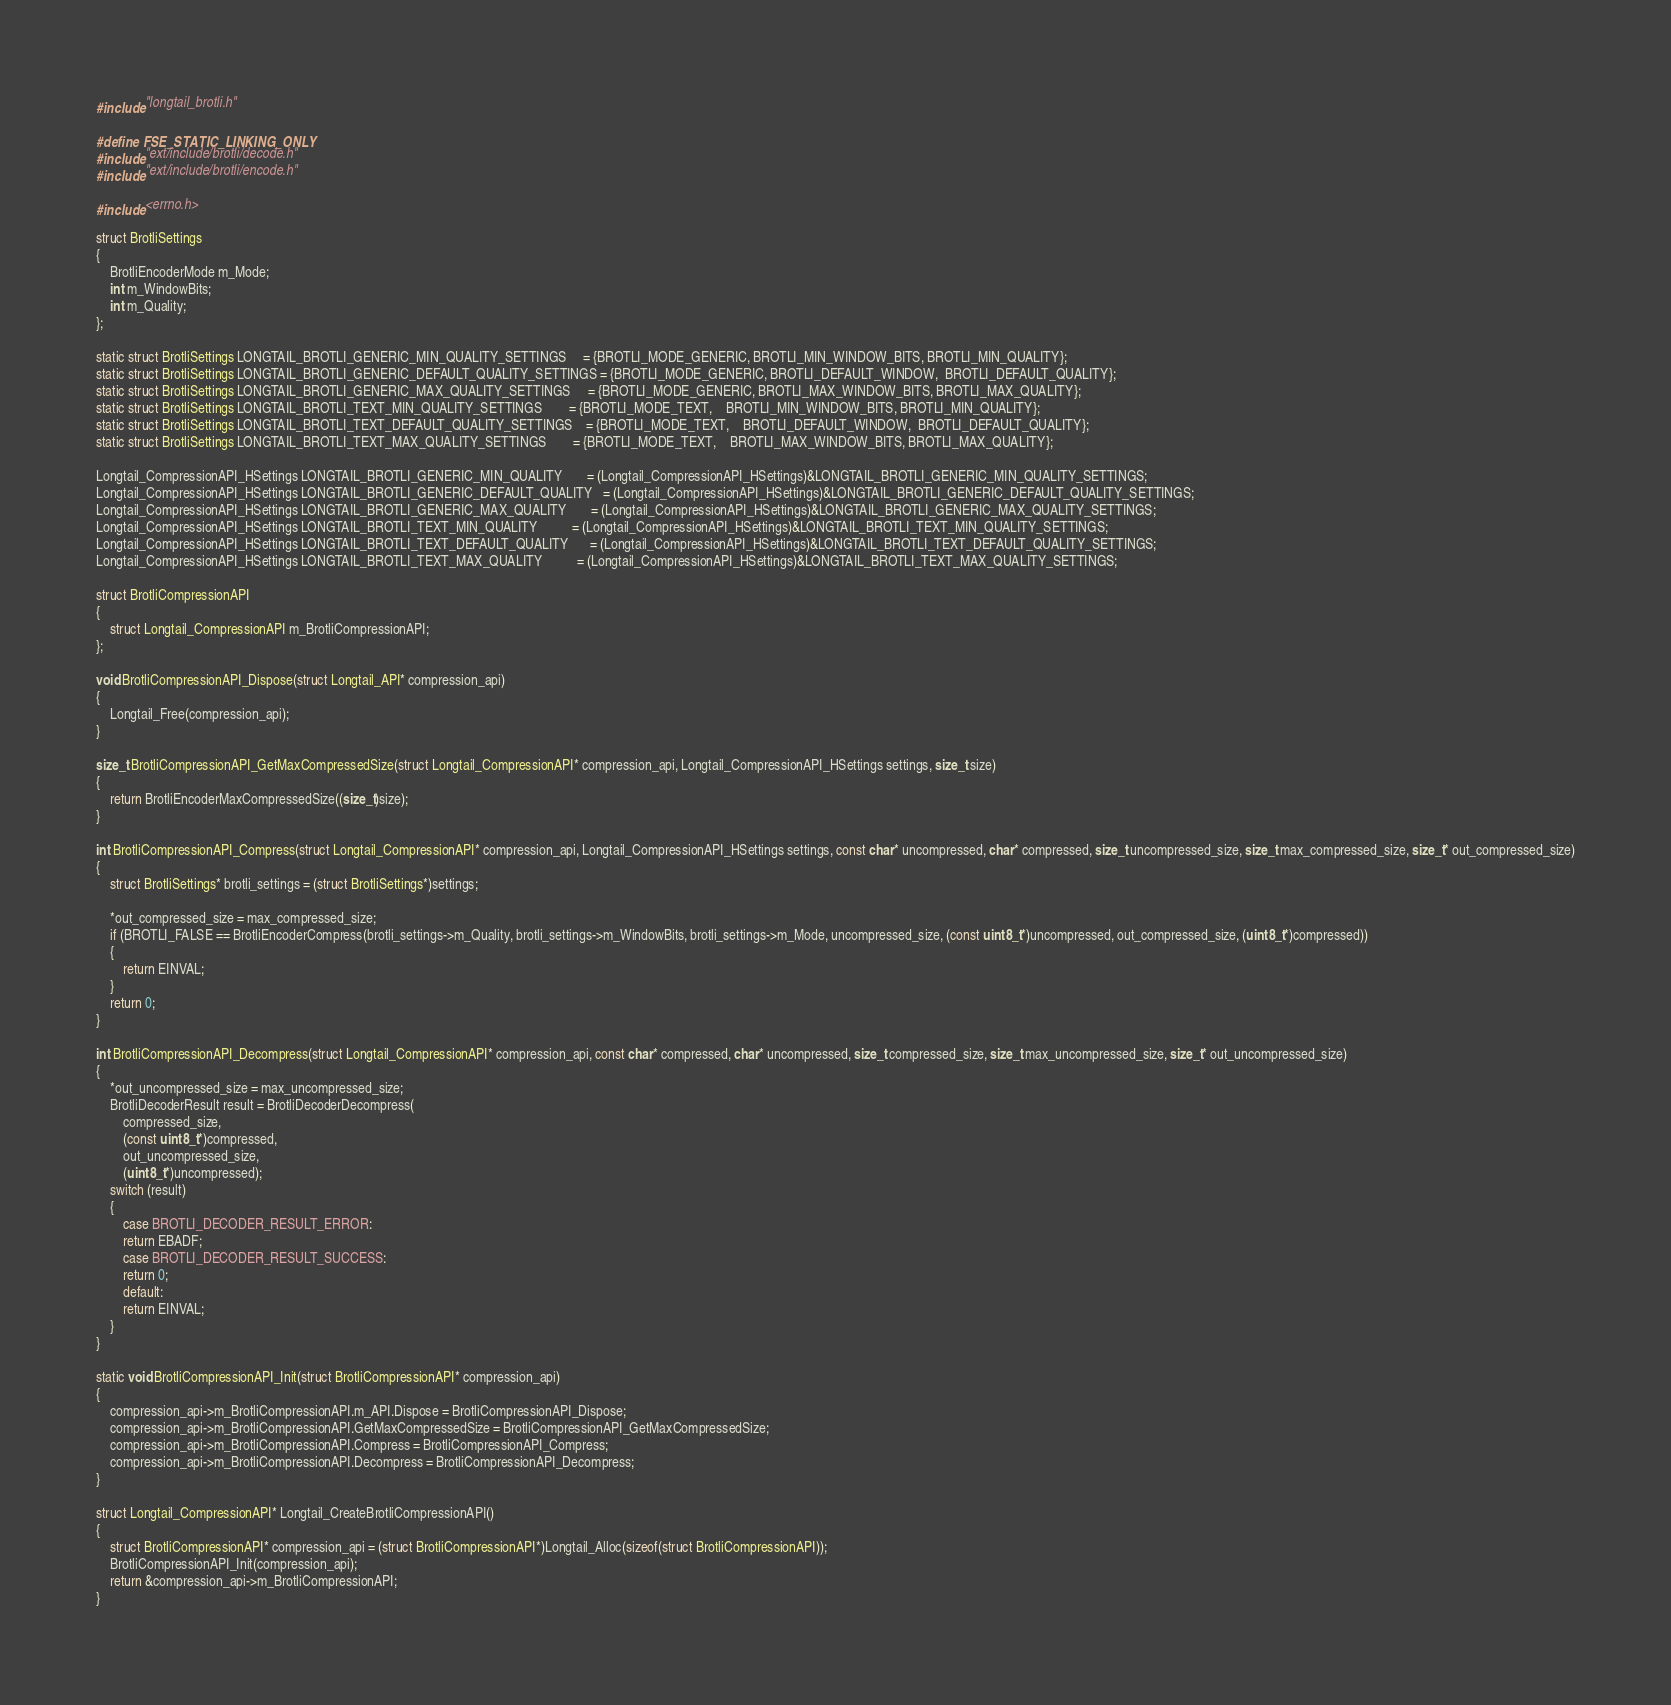Convert code to text. <code><loc_0><loc_0><loc_500><loc_500><_C_>#include "longtail_brotli.h"

#define FSE_STATIC_LINKING_ONLY
#include "ext/include/brotli/decode.h"
#include "ext/include/brotli/encode.h"

#include <errno.h>

struct BrotliSettings
{
    BrotliEncoderMode m_Mode;
    int m_WindowBits;
    int m_Quality;
};

static struct BrotliSettings LONGTAIL_BROTLI_GENERIC_MIN_QUALITY_SETTINGS     = {BROTLI_MODE_GENERIC, BROTLI_MIN_WINDOW_BITS, BROTLI_MIN_QUALITY};
static struct BrotliSettings LONGTAIL_BROTLI_GENERIC_DEFAULT_QUALITY_SETTINGS = {BROTLI_MODE_GENERIC, BROTLI_DEFAULT_WINDOW,  BROTLI_DEFAULT_QUALITY};
static struct BrotliSettings LONGTAIL_BROTLI_GENERIC_MAX_QUALITY_SETTINGS     = {BROTLI_MODE_GENERIC, BROTLI_MAX_WINDOW_BITS, BROTLI_MAX_QUALITY};
static struct BrotliSettings LONGTAIL_BROTLI_TEXT_MIN_QUALITY_SETTINGS        = {BROTLI_MODE_TEXT,    BROTLI_MIN_WINDOW_BITS, BROTLI_MIN_QUALITY};
static struct BrotliSettings LONGTAIL_BROTLI_TEXT_DEFAULT_QUALITY_SETTINGS    = {BROTLI_MODE_TEXT,    BROTLI_DEFAULT_WINDOW,  BROTLI_DEFAULT_QUALITY};
static struct BrotliSettings LONGTAIL_BROTLI_TEXT_MAX_QUALITY_SETTINGS        = {BROTLI_MODE_TEXT,    BROTLI_MAX_WINDOW_BITS, BROTLI_MAX_QUALITY};

Longtail_CompressionAPI_HSettings LONGTAIL_BROTLI_GENERIC_MIN_QUALITY       = (Longtail_CompressionAPI_HSettings)&LONGTAIL_BROTLI_GENERIC_MIN_QUALITY_SETTINGS;
Longtail_CompressionAPI_HSettings LONGTAIL_BROTLI_GENERIC_DEFAULT_QUALITY   = (Longtail_CompressionAPI_HSettings)&LONGTAIL_BROTLI_GENERIC_DEFAULT_QUALITY_SETTINGS;
Longtail_CompressionAPI_HSettings LONGTAIL_BROTLI_GENERIC_MAX_QUALITY       = (Longtail_CompressionAPI_HSettings)&LONGTAIL_BROTLI_GENERIC_MAX_QUALITY_SETTINGS;
Longtail_CompressionAPI_HSettings LONGTAIL_BROTLI_TEXT_MIN_QUALITY          = (Longtail_CompressionAPI_HSettings)&LONGTAIL_BROTLI_TEXT_MIN_QUALITY_SETTINGS;
Longtail_CompressionAPI_HSettings LONGTAIL_BROTLI_TEXT_DEFAULT_QUALITY      = (Longtail_CompressionAPI_HSettings)&LONGTAIL_BROTLI_TEXT_DEFAULT_QUALITY_SETTINGS;
Longtail_CompressionAPI_HSettings LONGTAIL_BROTLI_TEXT_MAX_QUALITY          = (Longtail_CompressionAPI_HSettings)&LONGTAIL_BROTLI_TEXT_MAX_QUALITY_SETTINGS;

struct BrotliCompressionAPI
{
    struct Longtail_CompressionAPI m_BrotliCompressionAPI;
};

void BrotliCompressionAPI_Dispose(struct Longtail_API* compression_api)
{
    Longtail_Free(compression_api);
}

size_t BrotliCompressionAPI_GetMaxCompressedSize(struct Longtail_CompressionAPI* compression_api, Longtail_CompressionAPI_HSettings settings, size_t size)
{
    return BrotliEncoderMaxCompressedSize((size_t)size);
}

int BrotliCompressionAPI_Compress(struct Longtail_CompressionAPI* compression_api, Longtail_CompressionAPI_HSettings settings, const char* uncompressed, char* compressed, size_t uncompressed_size, size_t max_compressed_size, size_t* out_compressed_size)
{
    struct BrotliSettings* brotli_settings = (struct BrotliSettings*)settings;

    *out_compressed_size = max_compressed_size;
    if (BROTLI_FALSE == BrotliEncoderCompress(brotli_settings->m_Quality, brotli_settings->m_WindowBits, brotli_settings->m_Mode, uncompressed_size, (const uint8_t*)uncompressed, out_compressed_size, (uint8_t*)compressed))
    {
        return EINVAL;
    }
    return 0;
}

int BrotliCompressionAPI_Decompress(struct Longtail_CompressionAPI* compression_api, const char* compressed, char* uncompressed, size_t compressed_size, size_t max_uncompressed_size, size_t* out_uncompressed_size)
{
    *out_uncompressed_size = max_uncompressed_size;
    BrotliDecoderResult result = BrotliDecoderDecompress(
        compressed_size,
        (const uint8_t*)compressed,
        out_uncompressed_size,
        (uint8_t*)uncompressed);
    switch (result)
    {
        case BROTLI_DECODER_RESULT_ERROR:
        return EBADF;
        case BROTLI_DECODER_RESULT_SUCCESS:
        return 0;
        default:
        return EINVAL;
    }
}

static void BrotliCompressionAPI_Init(struct BrotliCompressionAPI* compression_api)
{
    compression_api->m_BrotliCompressionAPI.m_API.Dispose = BrotliCompressionAPI_Dispose;
    compression_api->m_BrotliCompressionAPI.GetMaxCompressedSize = BrotliCompressionAPI_GetMaxCompressedSize;
    compression_api->m_BrotliCompressionAPI.Compress = BrotliCompressionAPI_Compress;
    compression_api->m_BrotliCompressionAPI.Decompress = BrotliCompressionAPI_Decompress;
}

struct Longtail_CompressionAPI* Longtail_CreateBrotliCompressionAPI()
{
    struct BrotliCompressionAPI* compression_api = (struct BrotliCompressionAPI*)Longtail_Alloc(sizeof(struct BrotliCompressionAPI));
    BrotliCompressionAPI_Init(compression_api);
    return &compression_api->m_BrotliCompressionAPI;
}



</code> 